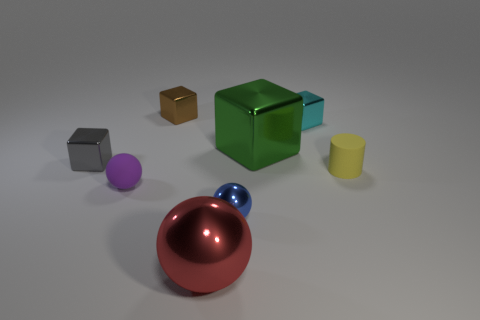Add 1 brown metal blocks. How many objects exist? 9 Subtract all metallic spheres. How many spheres are left? 1 Subtract all purple spheres. How many spheres are left? 2 Subtract 0 green cylinders. How many objects are left? 8 Subtract all cylinders. How many objects are left? 7 Subtract 1 spheres. How many spheres are left? 2 Subtract all blue balls. Subtract all yellow blocks. How many balls are left? 2 Subtract all green cubes. How many red balls are left? 1 Subtract all small yellow cylinders. Subtract all small yellow metallic cubes. How many objects are left? 7 Add 4 matte cylinders. How many matte cylinders are left? 5 